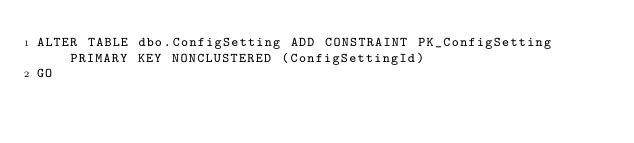Convert code to text. <code><loc_0><loc_0><loc_500><loc_500><_SQL_>ALTER TABLE dbo.ConfigSetting ADD CONSTRAINT PK_ConfigSetting PRIMARY KEY NONCLUSTERED (ConfigSettingId)
GO
 </code> 